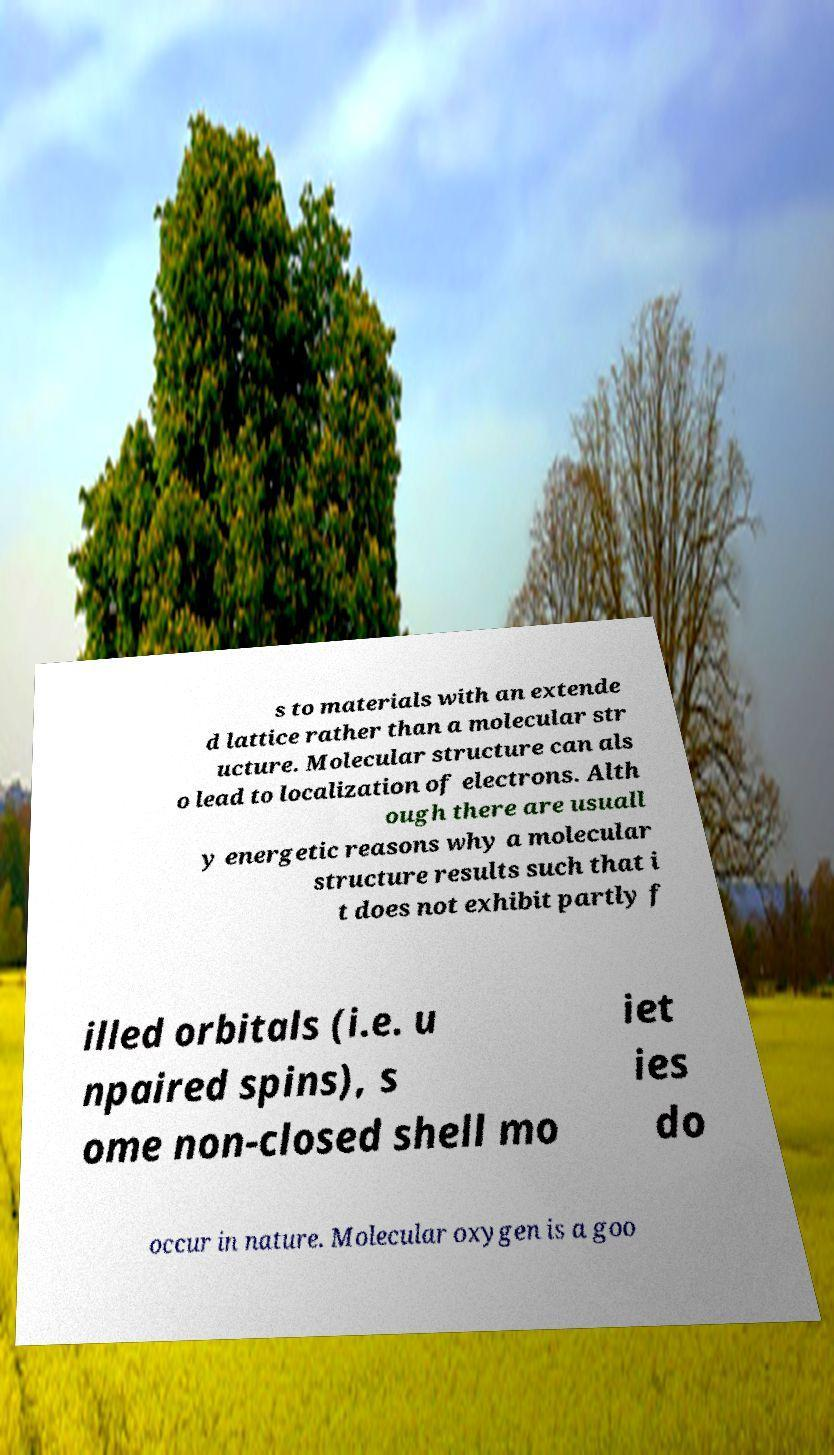What messages or text are displayed in this image? I need them in a readable, typed format. s to materials with an extende d lattice rather than a molecular str ucture. Molecular structure can als o lead to localization of electrons. Alth ough there are usuall y energetic reasons why a molecular structure results such that i t does not exhibit partly f illed orbitals (i.e. u npaired spins), s ome non-closed shell mo iet ies do occur in nature. Molecular oxygen is a goo 